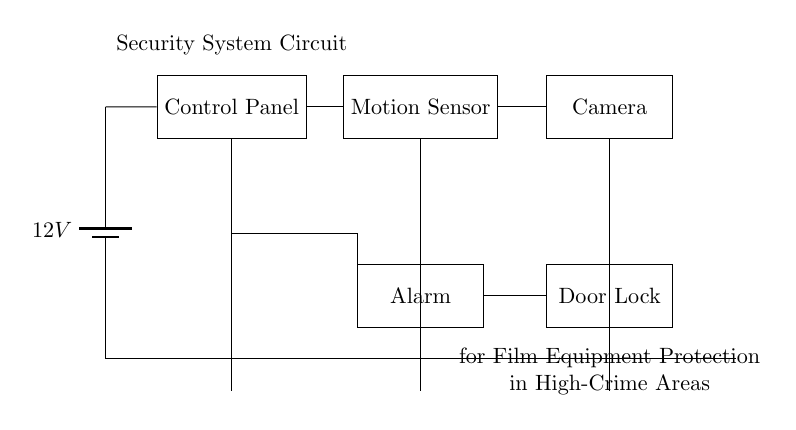What is the main power supply voltage? The circuit diagram specifies a battery as the main power supply, labeled with a voltage of 12 volts. This is indicated at the top left of the diagram where the battery symbol is shown.
Answer: 12 volts What components are connected to the control panel? The control panel connects to a motion sensor and an alarm system. The lines drawn from the control panel lead directly to these components, indicating they are part of the same circuit.
Answer: Motion sensor, Alarm Which component is connected to the alarm? The alarm is connected to the door lock as indicated by the direct line extending from the alarm to the door lock component. This shows that the alarm triggers the door lock in case of unauthorized motion detection.
Answer: Door lock How many sensors are in the circuit? There is only one motion sensor present in the circuit, as seen in the diagram where only one rectangle labeled "Motion Sensor" is shown.
Answer: One What is the role of the motion sensor in the circuit? The motion sensor detects movement in the vicinity to enhance security. When motion is detected, it sends a signal to the control panel, which can then activate other components like the alarm or door lock.
Answer: Detect movement What is the sequence of activation in an event of motion detection? The sequence begins with the motion sensor detecting movement, then sending a signal to the control panel. The control panel activates the alarm, which subsequently locks the door, ensuring security. This sequence is interpreted based on the flow of connections in the diagram.
Answer: Motion sensor → Control panel → Alarm → Door lock 